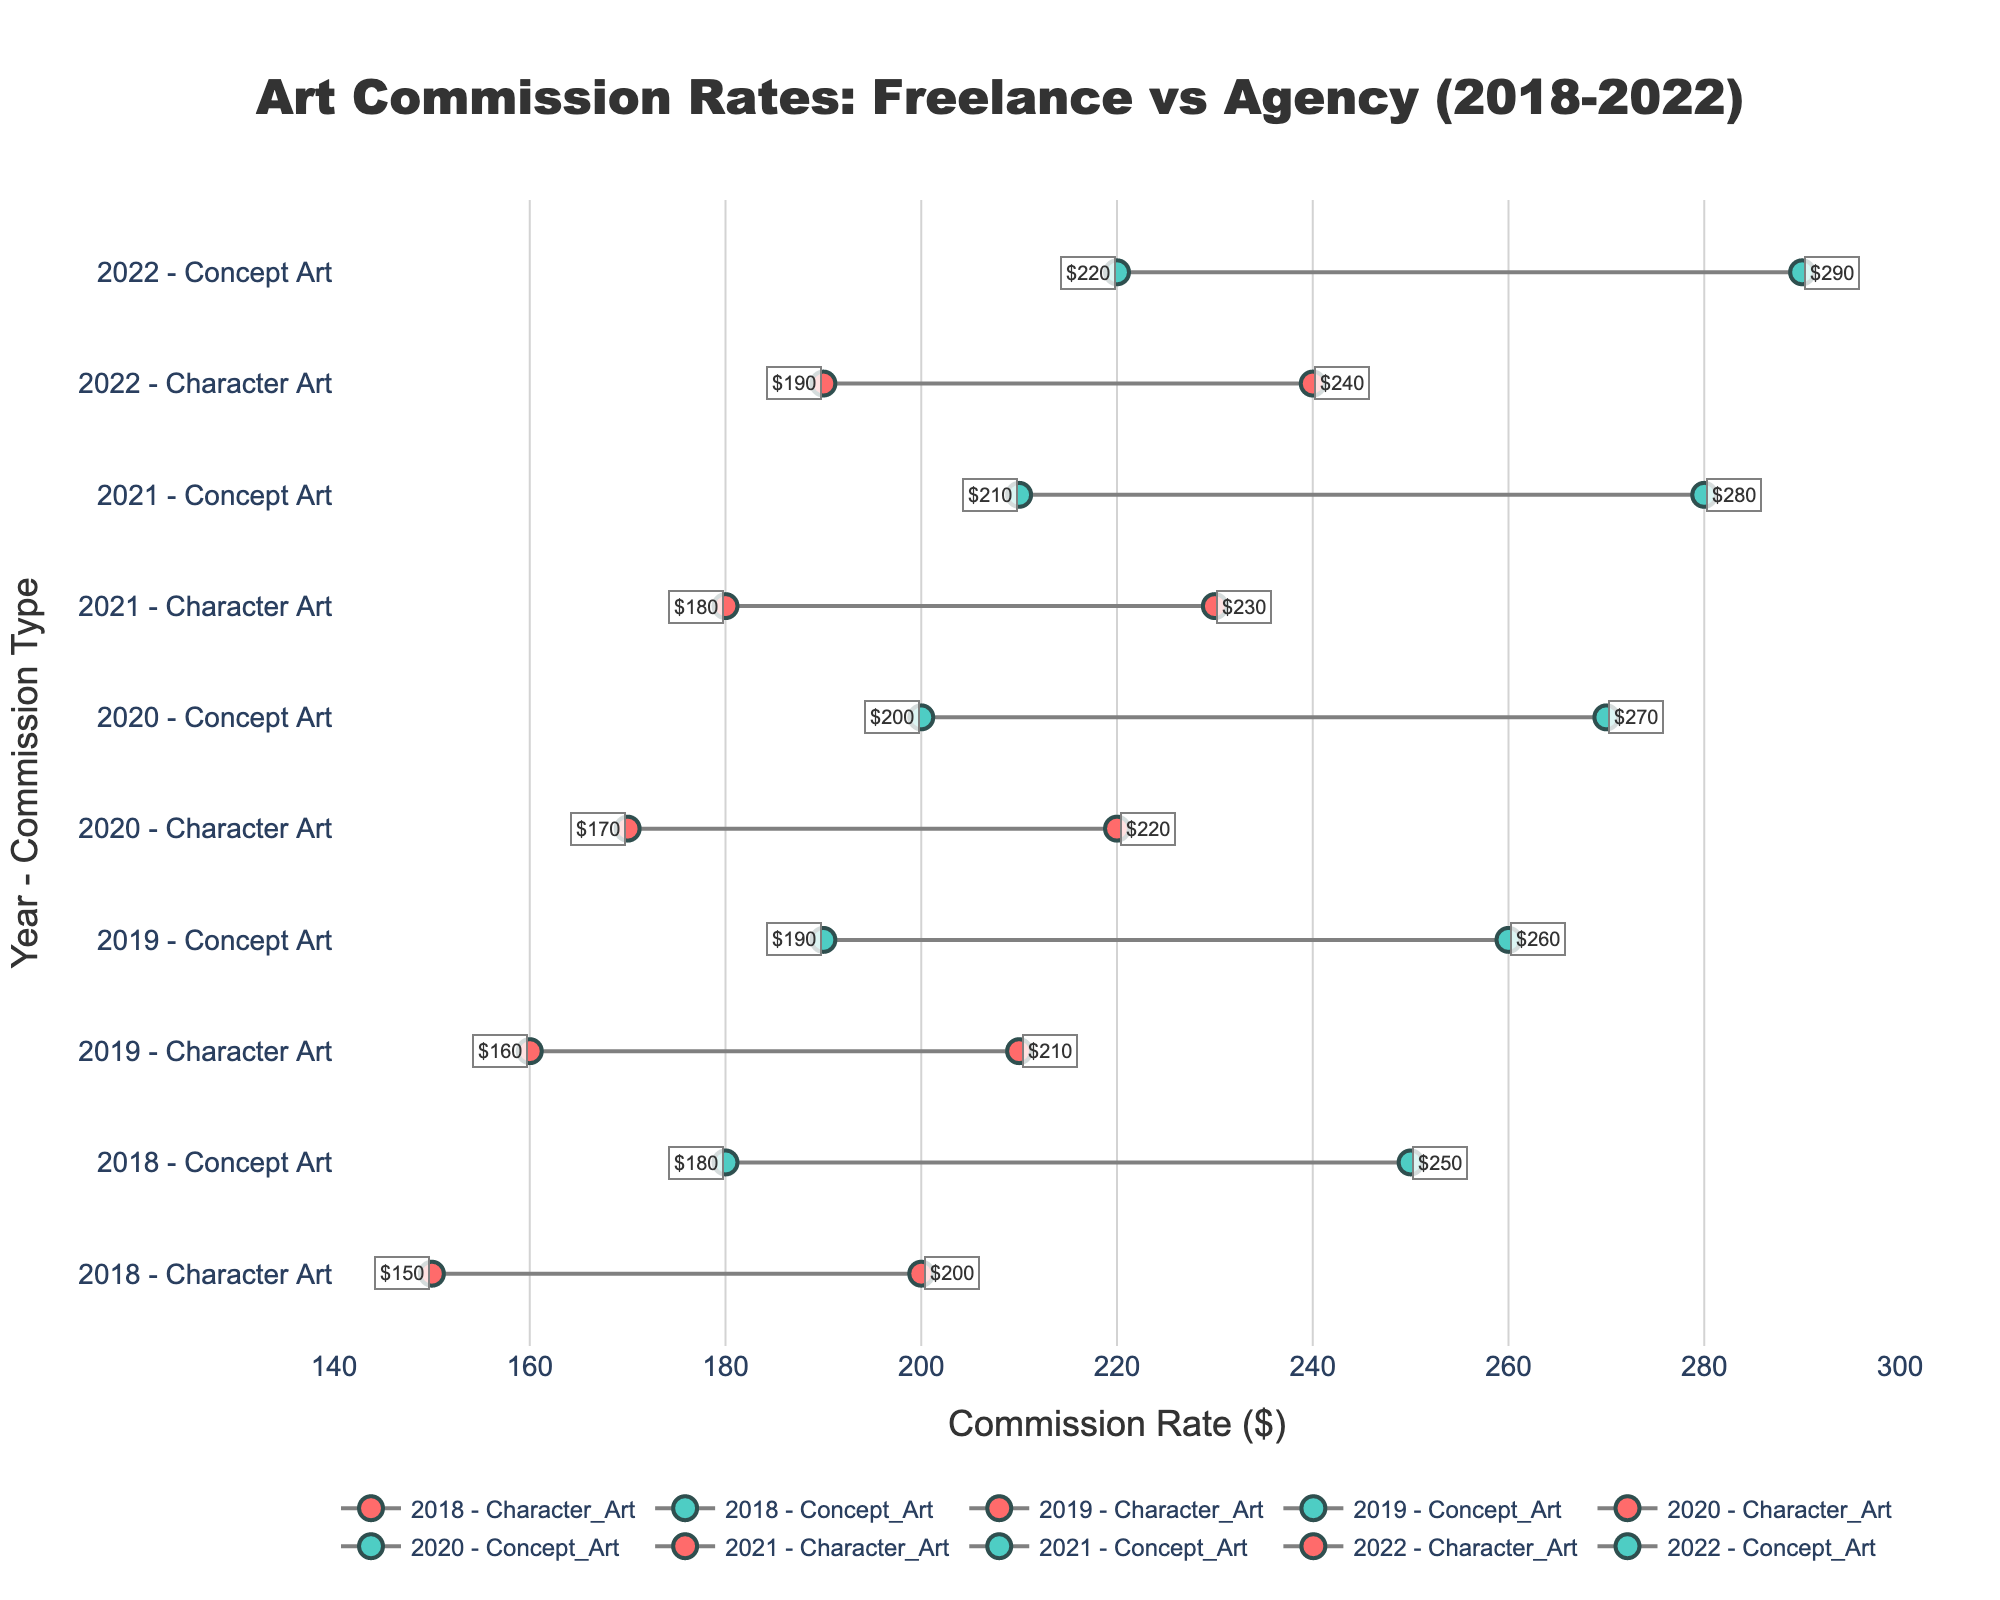What is the title of the plot? The title is located at the top center of the plot and it summarizes the content of the figure.
Answer: Art Commission Rates: Freelance vs Agency (2018-2022) What is the commission rate for Freelance Character Art in 2020? Locate the 2020 data point for Freelance Character Art and read the value marked on the x-axis.
Answer: 170 How do the commission rates compare between Freelance and Agency for Concept Art in 2019? Look for the Concept Art data point in 2019 and compare the markers for Freelance and Agency. Freelance has a lower rate than Agency.
Answer: Freelance is 190, Agency is 260 Which year had the highest commission rate for Agency Concept Art? Examine the Agency Concept Art rates over the years and identify the highest value.
Answer: 2022 What is the difference in commission rates between Freelance and Agency for Character Art in 2021? Find the 2021 data points for Character Art for both Freelance and Agency, then calculate the difference. Agency is 230 and Freelance is 180. The difference is 230 - 180.
Answer: 50 Which entity had a larger increase in commission rates for Character Art from 2018 to 2022? Calculate the difference in rates for Character Art between 2018 and 2022 for both Freelance and Agency, then compare the increases. Freelance: 190 - 150 = 40. Agency: 240 - 200 = 40. Both increased by 40.
Answer: Both had the same increase of 40 What is the trend of Freelance Concept Art rates from 2018 to 2022? Track the Freelance Concept Art commission rates from 2018 to 2022 to observe how the rates change over the years. They are consistently increasing every year.
Answer: Increasing trend What is the average commission rate for Agency Character Art over the years? Add the commission rates for Agency Character Art from 2018 to 2022 and divide by the number of years. (200 + 210 + 220 + 230 + 240) / 5 = 220
Answer: 220 Between Freelance and Agency, which entity generally has higher commission rates? Compare the general position of the Freelance and Agency data points in the plot. Notice that Agency consistently has higher markers.
Answer: Agency How much more did Freelance Concept Art rates increase compared to Freelance Character Art rates from 2018 to 2022? Find the increase in rates for both types from 2018 to 2022: Concept Art: 220 - 180 = 40, Character Art: 190 - 150 = 40. Both increased by 40, so the difference is 0.
Answer: 0 